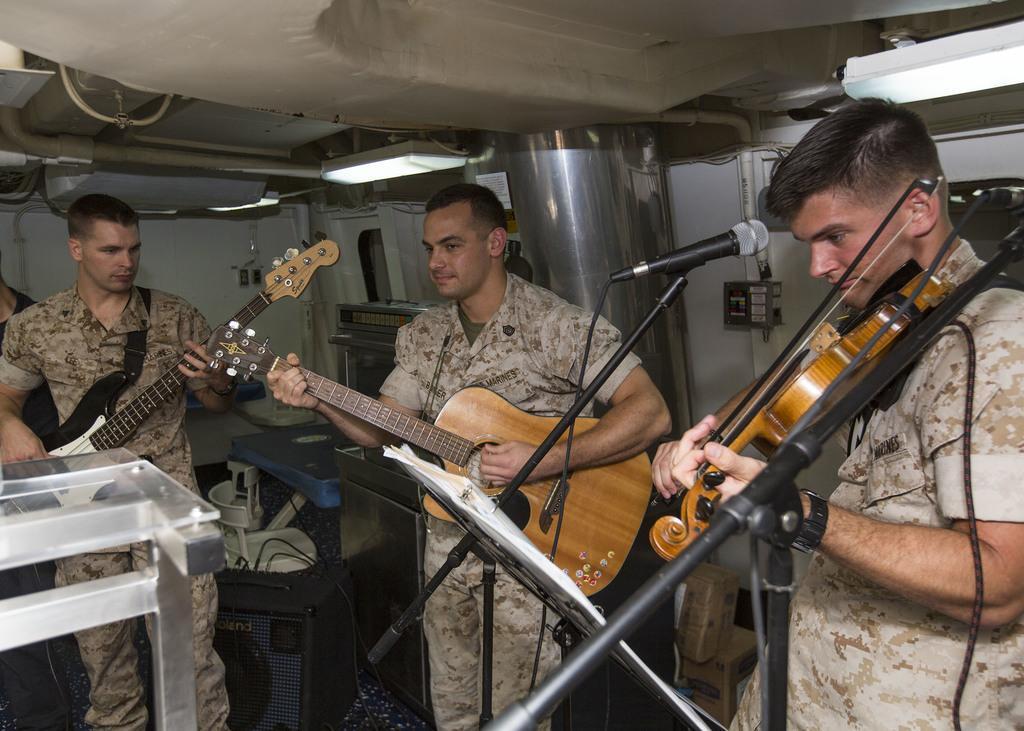Please provide a concise description of this image. Here in this picture we can see three men in a military uniform standing over a place and the man in the front is playing a violin and the other two men are playing guitars and we can see microphones present in front of them and we can see lights present over there. 